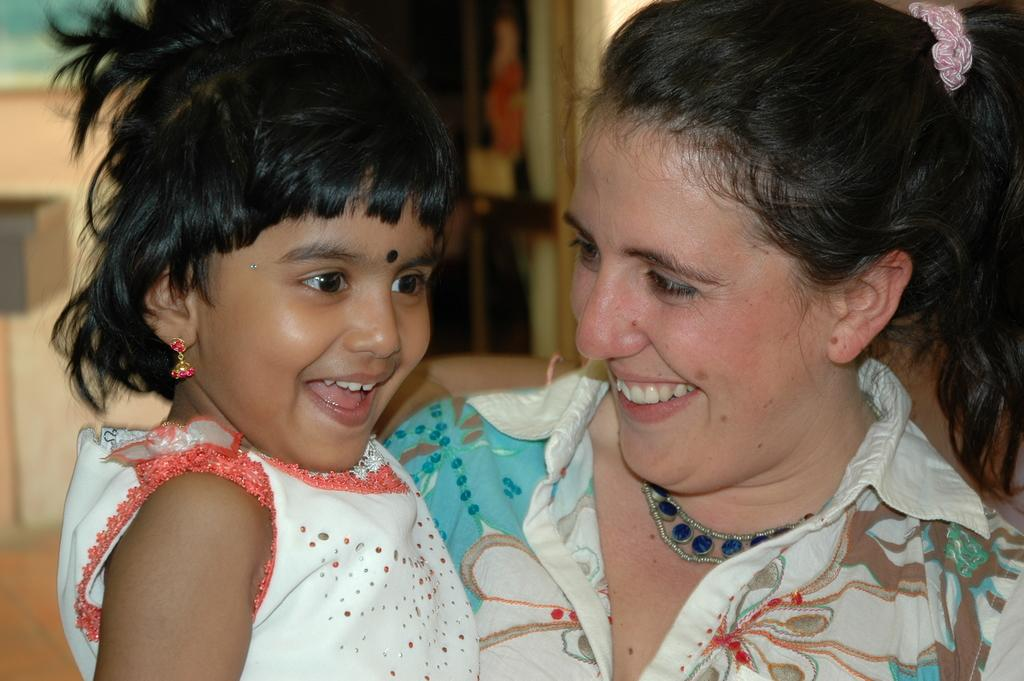Who are the people in the image? There is a woman and a girl in the image. What expressions do the woman and the girl have? Both the woman and the girl are smiling. Can you describe the background of the image? The background of the image is blurred. Where is the library located in the image? There is no library present in the image. What type of tooth can be seen in the image? There are no teeth visible in the image. --- Facts: 1. There is a car in the image. 2. The car is parked on the street. 3. There are buildings in the background of the image. 4. The street is empty. Absurd Topics: ocean, bird, mountain Conversation: What is the main subject of the image? The main subject of the image is a car. Where is the car located in the image? The car is parked on the street. What can be seen in the background of the image? There are buildings in the background of the image. How many vehicles are visible in the image? There is only one car visible in the image. Reasoning: Let's think step by step in order to produce the conversation. We start by identifying the main subject of the image, which is the car. Then, we describe the car's location, noting that it is parked on the street. Next, we observe the background of the image, which includes buildings. Finally, we count the number of vehicles visible in the image, which is one car. Absurd Question/Answer: What type of ocean can be seen in the image? There is no ocean present in the image. How many birds are visible on the car in the image? There are no birds visible on the car in the image. 